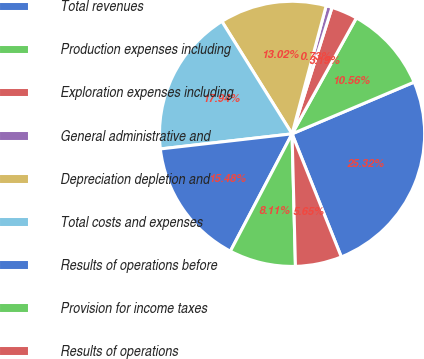Convert chart to OTSL. <chart><loc_0><loc_0><loc_500><loc_500><pie_chart><fcel>Total revenues<fcel>Production expenses including<fcel>Exploration expenses including<fcel>General administrative and<fcel>Depreciation depletion and<fcel>Total costs and expenses<fcel>Results of operations before<fcel>Provision for income taxes<fcel>Results of operations<nl><fcel>25.32%<fcel>10.56%<fcel>3.19%<fcel>0.73%<fcel>13.02%<fcel>17.94%<fcel>15.48%<fcel>8.11%<fcel>5.65%<nl></chart> 